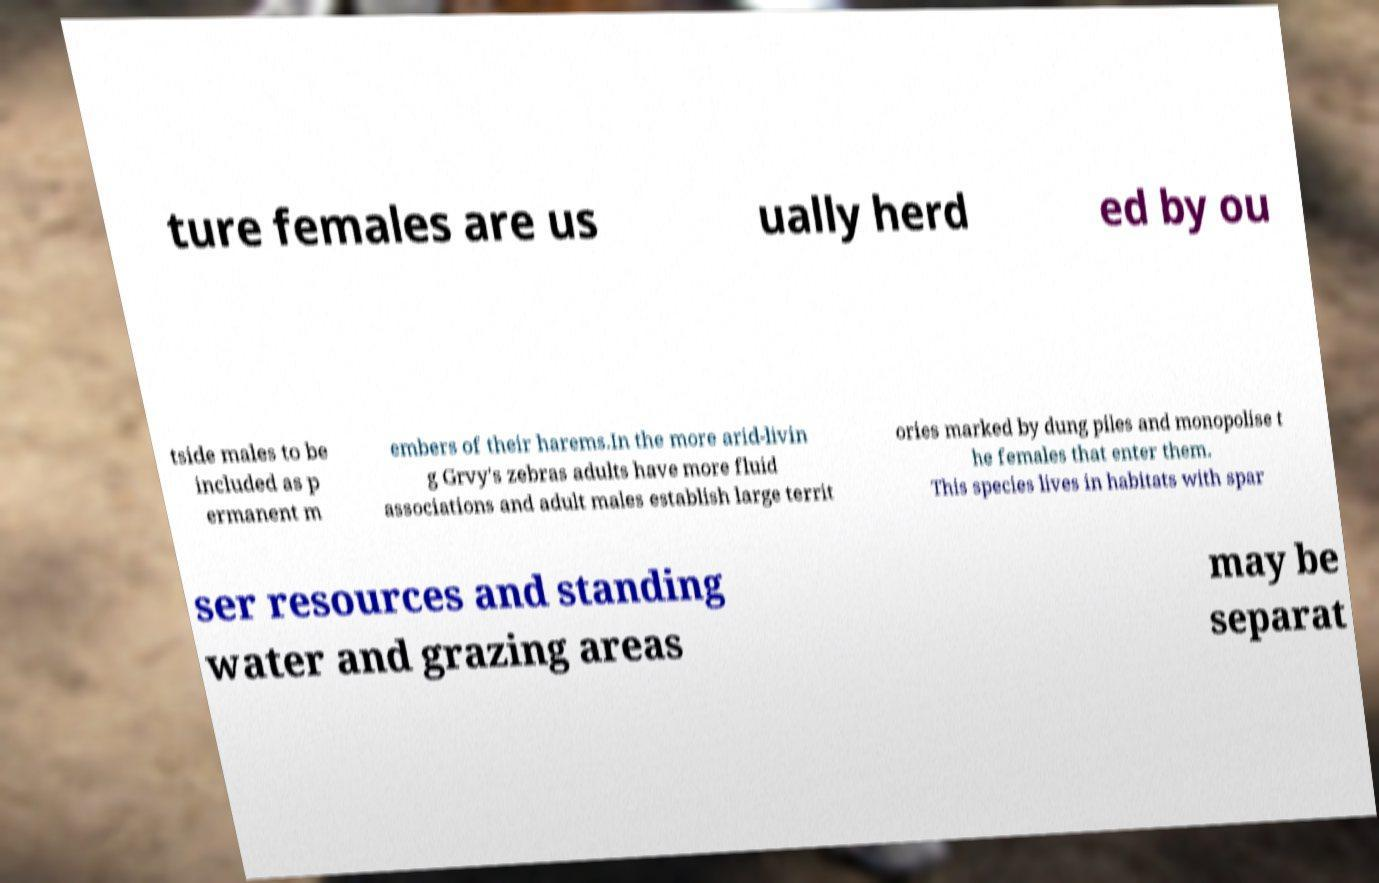There's text embedded in this image that I need extracted. Can you transcribe it verbatim? ture females are us ually herd ed by ou tside males to be included as p ermanent m embers of their harems.In the more arid-livin g Grvy's zebras adults have more fluid associations and adult males establish large territ ories marked by dung piles and monopolise t he females that enter them. This species lives in habitats with spar ser resources and standing water and grazing areas may be separat 